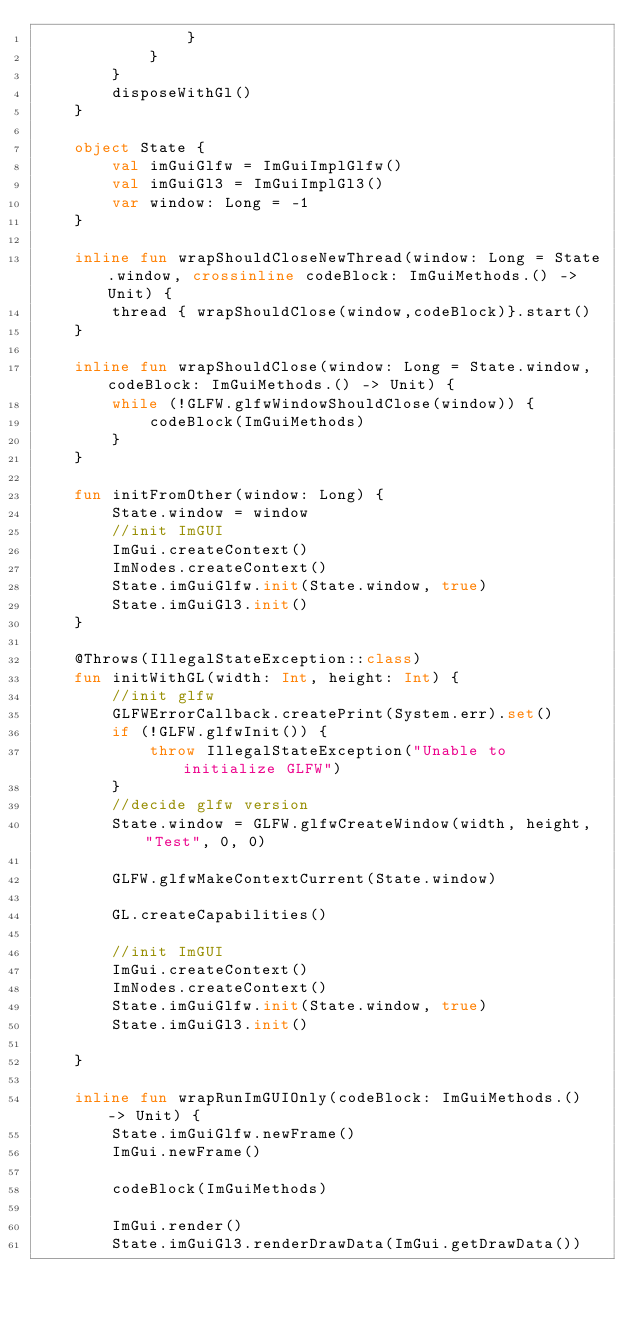<code> <loc_0><loc_0><loc_500><loc_500><_Kotlin_>                }
            }
        }
        disposeWithGl()
    }

    object State {
        val imGuiGlfw = ImGuiImplGlfw()
        val imGuiGl3 = ImGuiImplGl3()
        var window: Long = -1
    }

    inline fun wrapShouldCloseNewThread(window: Long = State.window, crossinline codeBlock: ImGuiMethods.() -> Unit) {
        thread { wrapShouldClose(window,codeBlock)}.start()
    }

    inline fun wrapShouldClose(window: Long = State.window, codeBlock: ImGuiMethods.() -> Unit) {
        while (!GLFW.glfwWindowShouldClose(window)) {
            codeBlock(ImGuiMethods)
        }
    }

    fun initFromOther(window: Long) {
        State.window = window
        //init ImGUI
        ImGui.createContext()
        ImNodes.createContext()
        State.imGuiGlfw.init(State.window, true)
        State.imGuiGl3.init()
    }

    @Throws(IllegalStateException::class)
    fun initWithGL(width: Int, height: Int) {
        //init glfw
        GLFWErrorCallback.createPrint(System.err).set()
        if (!GLFW.glfwInit()) {
            throw IllegalStateException("Unable to initialize GLFW")
        }
        //decide glfw version
        State.window = GLFW.glfwCreateWindow(width, height, "Test", 0, 0)

        GLFW.glfwMakeContextCurrent(State.window)

        GL.createCapabilities()

        //init ImGUI
        ImGui.createContext()
        ImNodes.createContext()
        State.imGuiGlfw.init(State.window, true)
        State.imGuiGl3.init()

    }

    inline fun wrapRunImGUIOnly(codeBlock: ImGuiMethods.() -> Unit) {
        State.imGuiGlfw.newFrame()
        ImGui.newFrame()

        codeBlock(ImGuiMethods)

        ImGui.render()
        State.imGuiGl3.renderDrawData(ImGui.getDrawData())</code> 